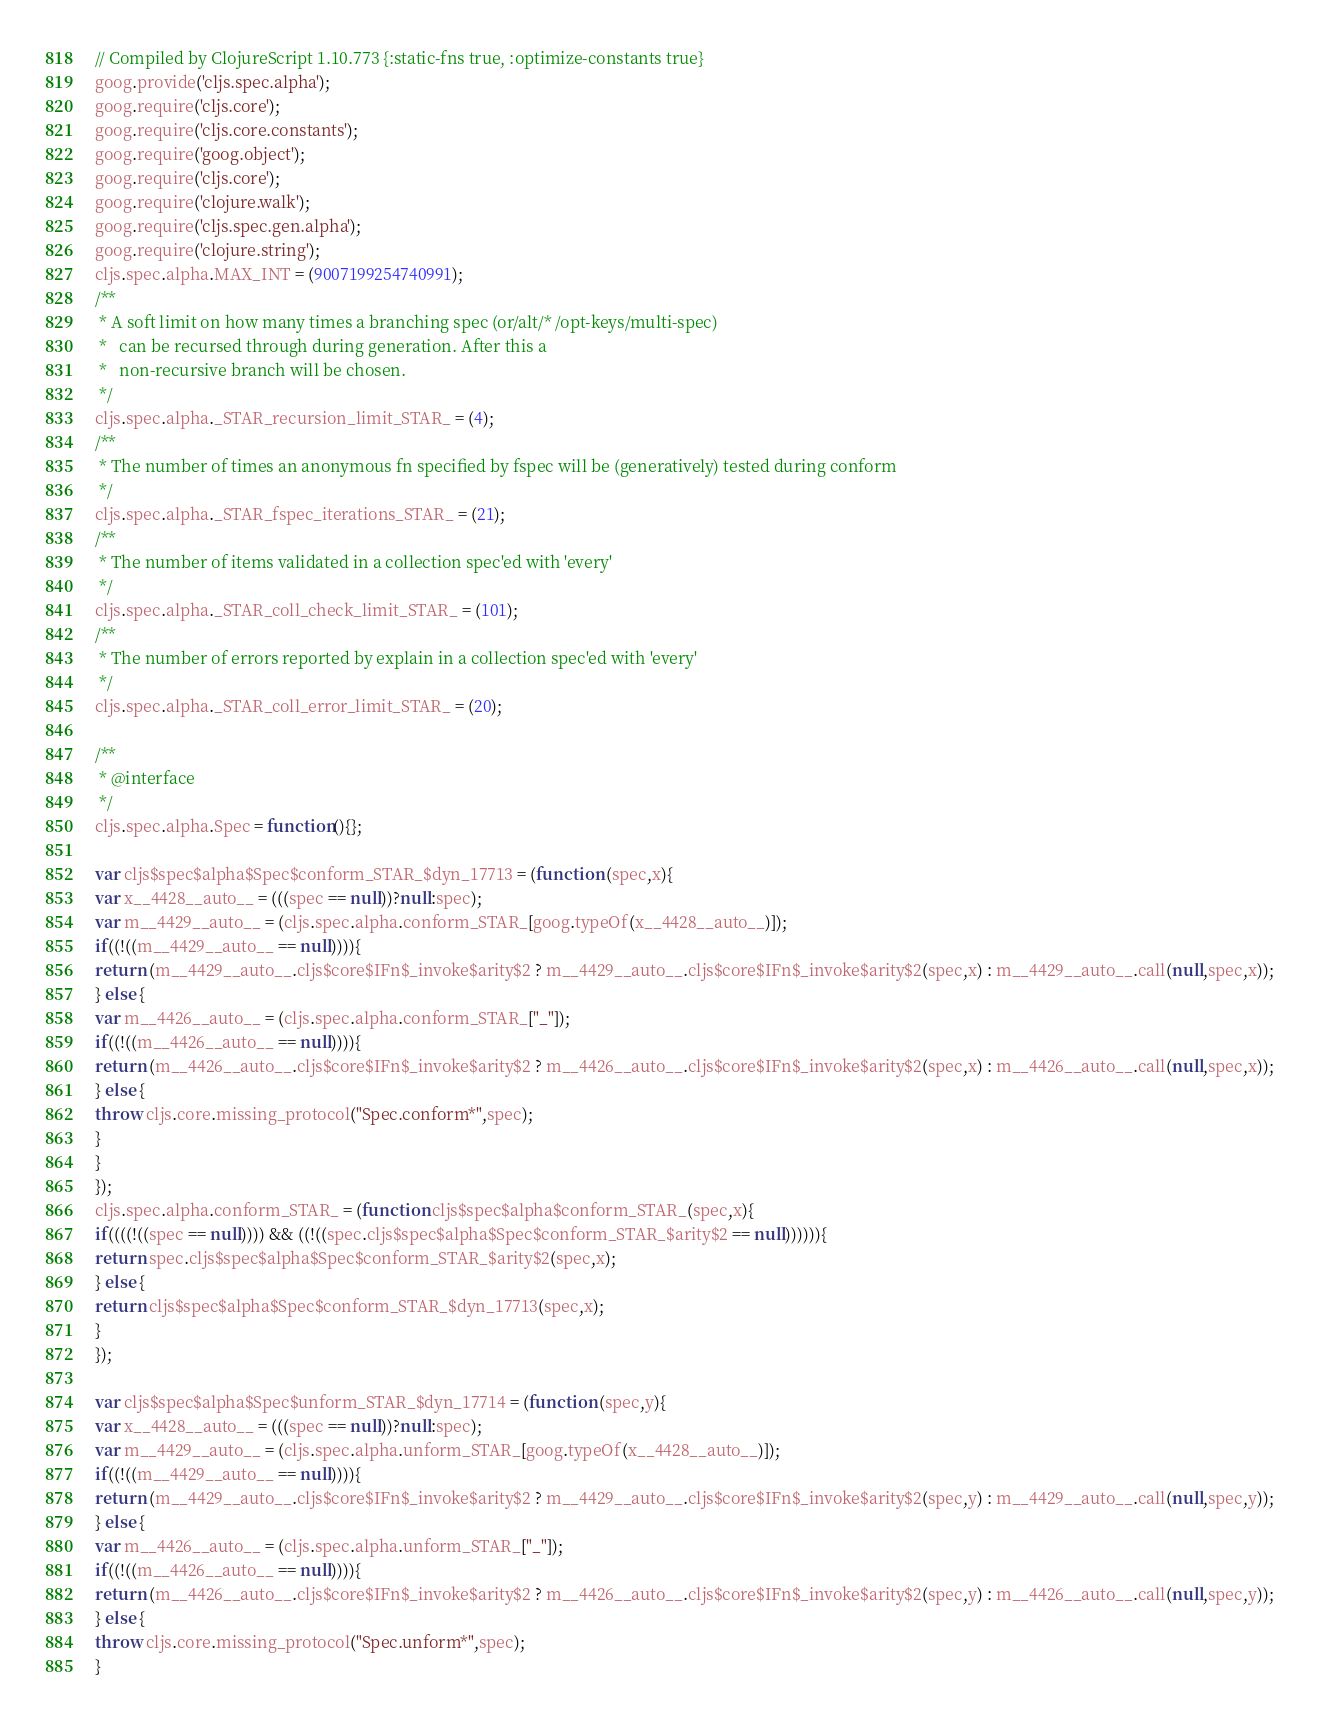<code> <loc_0><loc_0><loc_500><loc_500><_JavaScript_>// Compiled by ClojureScript 1.10.773 {:static-fns true, :optimize-constants true}
goog.provide('cljs.spec.alpha');
goog.require('cljs.core');
goog.require('cljs.core.constants');
goog.require('goog.object');
goog.require('cljs.core');
goog.require('clojure.walk');
goog.require('cljs.spec.gen.alpha');
goog.require('clojure.string');
cljs.spec.alpha.MAX_INT = (9007199254740991);
/**
 * A soft limit on how many times a branching spec (or/alt/* /opt-keys/multi-spec)
 *   can be recursed through during generation. After this a
 *   non-recursive branch will be chosen.
 */
cljs.spec.alpha._STAR_recursion_limit_STAR_ = (4);
/**
 * The number of times an anonymous fn specified by fspec will be (generatively) tested during conform
 */
cljs.spec.alpha._STAR_fspec_iterations_STAR_ = (21);
/**
 * The number of items validated in a collection spec'ed with 'every'
 */
cljs.spec.alpha._STAR_coll_check_limit_STAR_ = (101);
/**
 * The number of errors reported by explain in a collection spec'ed with 'every'
 */
cljs.spec.alpha._STAR_coll_error_limit_STAR_ = (20);

/**
 * @interface
 */
cljs.spec.alpha.Spec = function(){};

var cljs$spec$alpha$Spec$conform_STAR_$dyn_17713 = (function (spec,x){
var x__4428__auto__ = (((spec == null))?null:spec);
var m__4429__auto__ = (cljs.spec.alpha.conform_STAR_[goog.typeOf(x__4428__auto__)]);
if((!((m__4429__auto__ == null)))){
return (m__4429__auto__.cljs$core$IFn$_invoke$arity$2 ? m__4429__auto__.cljs$core$IFn$_invoke$arity$2(spec,x) : m__4429__auto__.call(null,spec,x));
} else {
var m__4426__auto__ = (cljs.spec.alpha.conform_STAR_["_"]);
if((!((m__4426__auto__ == null)))){
return (m__4426__auto__.cljs$core$IFn$_invoke$arity$2 ? m__4426__auto__.cljs$core$IFn$_invoke$arity$2(spec,x) : m__4426__auto__.call(null,spec,x));
} else {
throw cljs.core.missing_protocol("Spec.conform*",spec);
}
}
});
cljs.spec.alpha.conform_STAR_ = (function cljs$spec$alpha$conform_STAR_(spec,x){
if((((!((spec == null)))) && ((!((spec.cljs$spec$alpha$Spec$conform_STAR_$arity$2 == null)))))){
return spec.cljs$spec$alpha$Spec$conform_STAR_$arity$2(spec,x);
} else {
return cljs$spec$alpha$Spec$conform_STAR_$dyn_17713(spec,x);
}
});

var cljs$spec$alpha$Spec$unform_STAR_$dyn_17714 = (function (spec,y){
var x__4428__auto__ = (((spec == null))?null:spec);
var m__4429__auto__ = (cljs.spec.alpha.unform_STAR_[goog.typeOf(x__4428__auto__)]);
if((!((m__4429__auto__ == null)))){
return (m__4429__auto__.cljs$core$IFn$_invoke$arity$2 ? m__4429__auto__.cljs$core$IFn$_invoke$arity$2(spec,y) : m__4429__auto__.call(null,spec,y));
} else {
var m__4426__auto__ = (cljs.spec.alpha.unform_STAR_["_"]);
if((!((m__4426__auto__ == null)))){
return (m__4426__auto__.cljs$core$IFn$_invoke$arity$2 ? m__4426__auto__.cljs$core$IFn$_invoke$arity$2(spec,y) : m__4426__auto__.call(null,spec,y));
} else {
throw cljs.core.missing_protocol("Spec.unform*",spec);
}</code> 